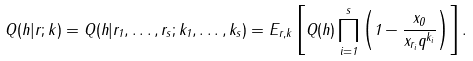<formula> <loc_0><loc_0><loc_500><loc_500>Q ( h | r ; k ) = Q ( h | r _ { 1 } , \dots , r _ { s } ; k _ { 1 } , \dots , k _ { s } ) = E _ { r , k } \left [ Q ( h ) \prod _ { i = 1 } ^ { s } \left ( 1 - \frac { x _ { 0 } } { x _ { r _ { i } } q ^ { k _ { i } } } \right ) \right ] .</formula> 